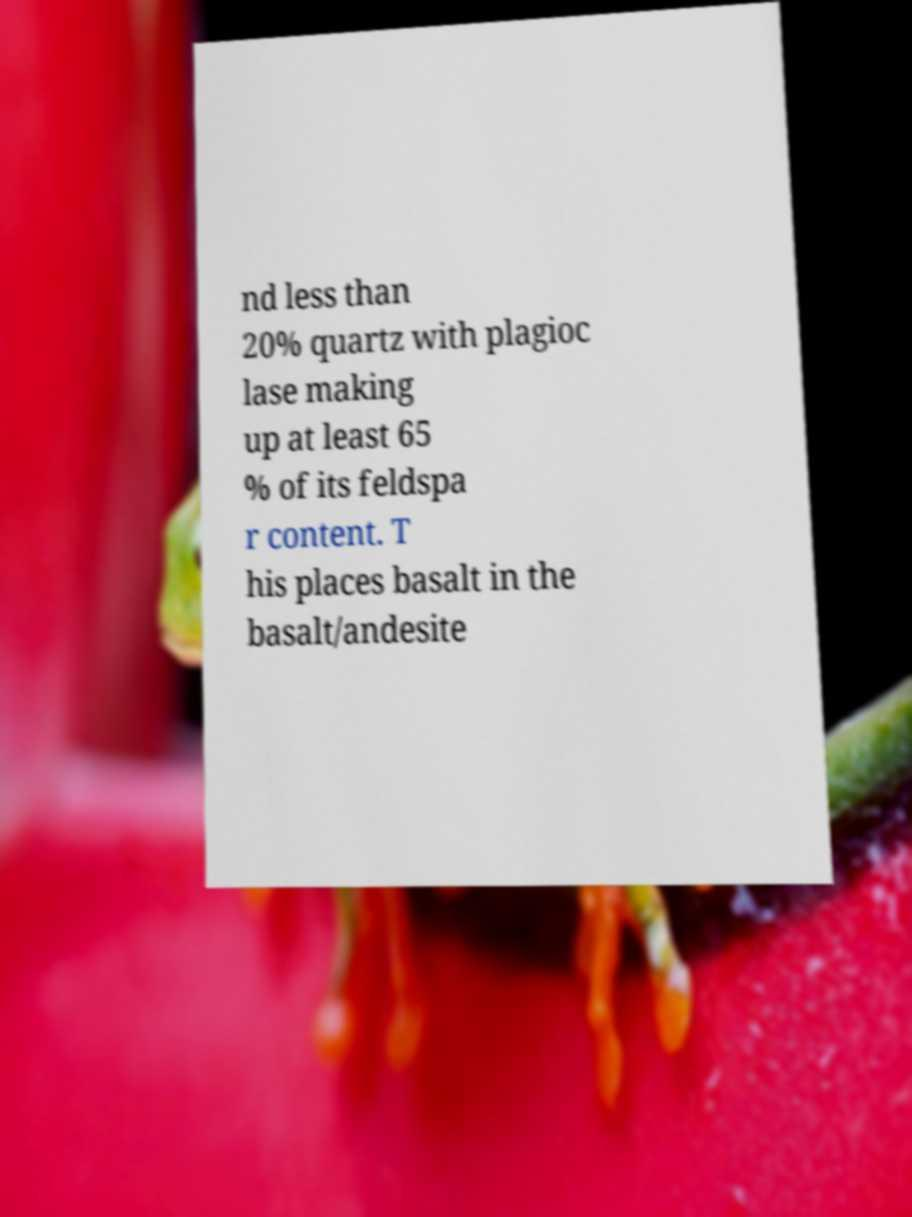What messages or text are displayed in this image? I need them in a readable, typed format. nd less than 20% quartz with plagioc lase making up at least 65 % of its feldspa r content. T his places basalt in the basalt/andesite 